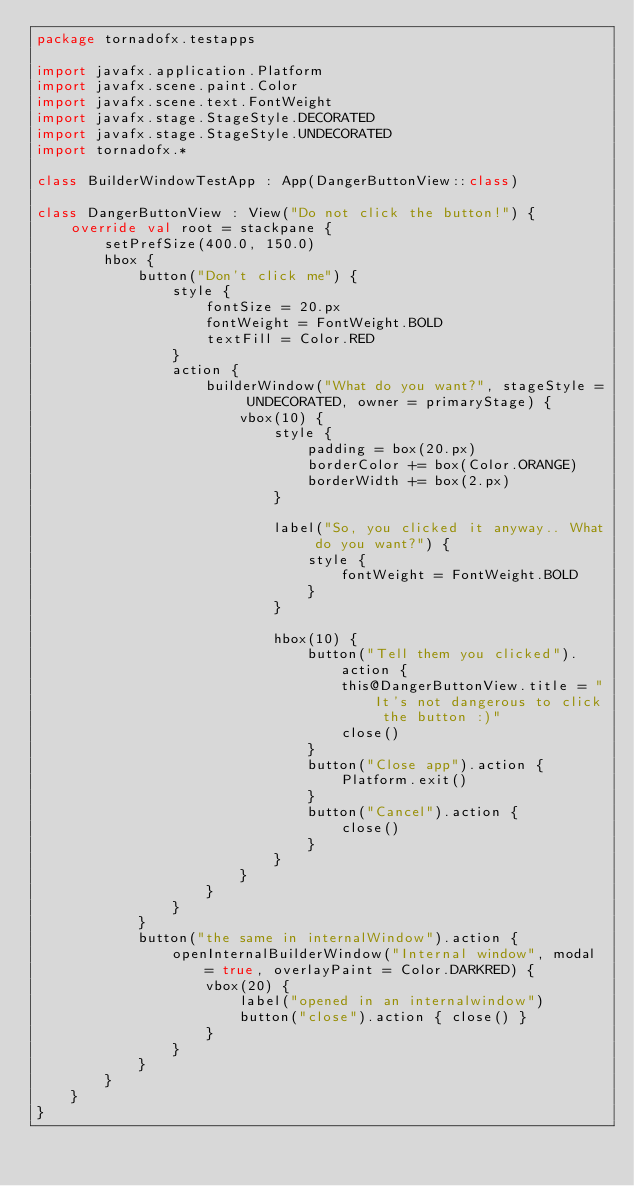Convert code to text. <code><loc_0><loc_0><loc_500><loc_500><_Kotlin_>package tornadofx.testapps

import javafx.application.Platform
import javafx.scene.paint.Color
import javafx.scene.text.FontWeight
import javafx.stage.StageStyle.DECORATED
import javafx.stage.StageStyle.UNDECORATED
import tornadofx.*

class BuilderWindowTestApp : App(DangerButtonView::class)

class DangerButtonView : View("Do not click the button!") {
    override val root = stackpane {
        setPrefSize(400.0, 150.0)
        hbox {
            button("Don't click me") {
                style {
                    fontSize = 20.px
                    fontWeight = FontWeight.BOLD
                    textFill = Color.RED
                }
                action {
                    builderWindow("What do you want?", stageStyle = UNDECORATED, owner = primaryStage) {
                        vbox(10) {
                            style {
                                padding = box(20.px)
                                borderColor += box(Color.ORANGE)
                                borderWidth += box(2.px)
                            }

                            label("So, you clicked it anyway.. What do you want?") {
                                style {
                                    fontWeight = FontWeight.BOLD
                                }
                            }

                            hbox(10) {
                                button("Tell them you clicked").action {
                                    this@DangerButtonView.title = "It's not dangerous to click the button :)"
                                    close()
                                }
                                button("Close app").action {
                                    Platform.exit()
                                }
                                button("Cancel").action {
                                    close()
                                }
                            }
                        }
                    }
                }
            }
            button("the same in internalWindow").action {
                openInternalBuilderWindow("Internal window", modal = true, overlayPaint = Color.DARKRED) {
                    vbox(20) {
                        label("opened in an internalwindow")
                        button("close").action { close() }
                    }
                }
            }
        }
    }
}</code> 